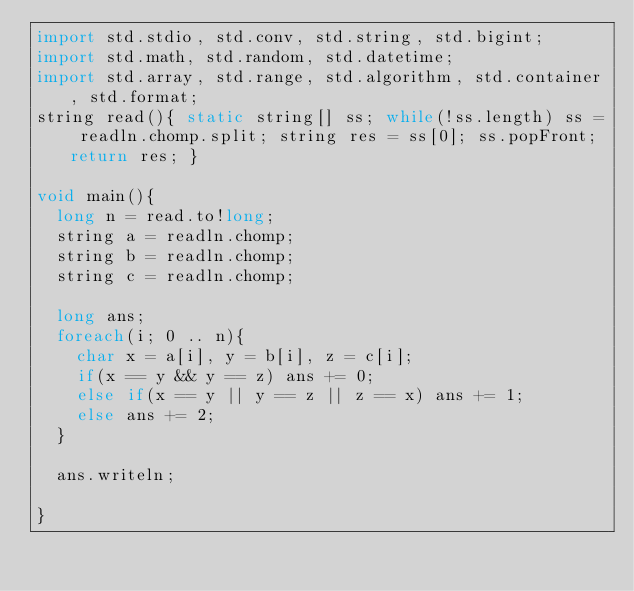<code> <loc_0><loc_0><loc_500><loc_500><_D_>import std.stdio, std.conv, std.string, std.bigint;
import std.math, std.random, std.datetime;
import std.array, std.range, std.algorithm, std.container, std.format;
string read(){ static string[] ss; while(!ss.length) ss = readln.chomp.split; string res = ss[0]; ss.popFront; return res; }

void main(){
	long n = read.to!long;
	string a = readln.chomp;
	string b = readln.chomp;
	string c = readln.chomp;
	
	long ans;
	foreach(i; 0 .. n){
		char x = a[i], y = b[i], z = c[i];
		if(x == y && y == z) ans += 0;
		else if(x == y || y == z || z == x) ans += 1;
		else ans += 2;
	}
	
	ans.writeln;
	
}
</code> 